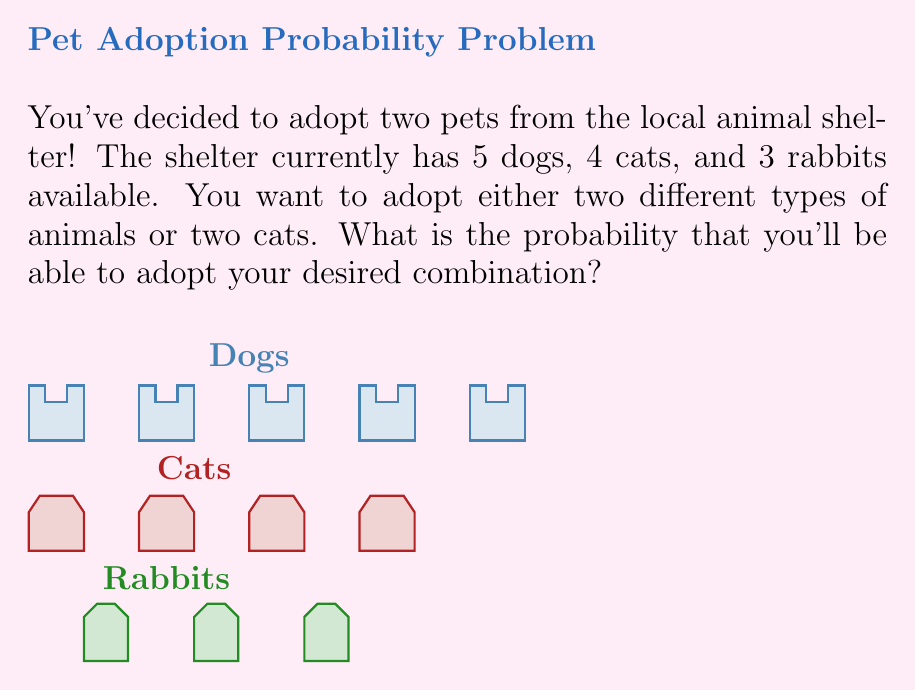Could you help me with this problem? Let's approach this step-by-step:

1) First, we need to calculate the total number of ways to choose 2 pets from the shelter:
   Total pets = 5 + 4 + 3 = 12
   Total combinations = $\binom{12}{2} = \frac{12!}{2!(12-2)!} = 66$

2) Now, let's count the favorable outcomes:
   a) Dog and Cat: $5 \times 4 = 20$ ways
   b) Dog and Rabbit: $5 \times 3 = 15$ ways
   c) Cat and Rabbit: $4 \times 3 = 12$ ways
   d) Two Cats: $\binom{4}{2} = \frac{4!}{2!(4-2)!} = 6$ ways

3) Total favorable outcomes: 20 + 15 + 12 + 6 = 53

4) The probability is then:
   $$P(\text{desired combination}) = \frac{\text{favorable outcomes}}{\text{total outcomes}} = \frac{53}{66}$$

5) To simplify this fraction:
   $$\frac{53}{66} = \frac{53}{2 \times 3 \times 11} = \frac{53}{66}$$
   This fraction can't be simplified further.
Answer: $\frac{53}{66}$ 